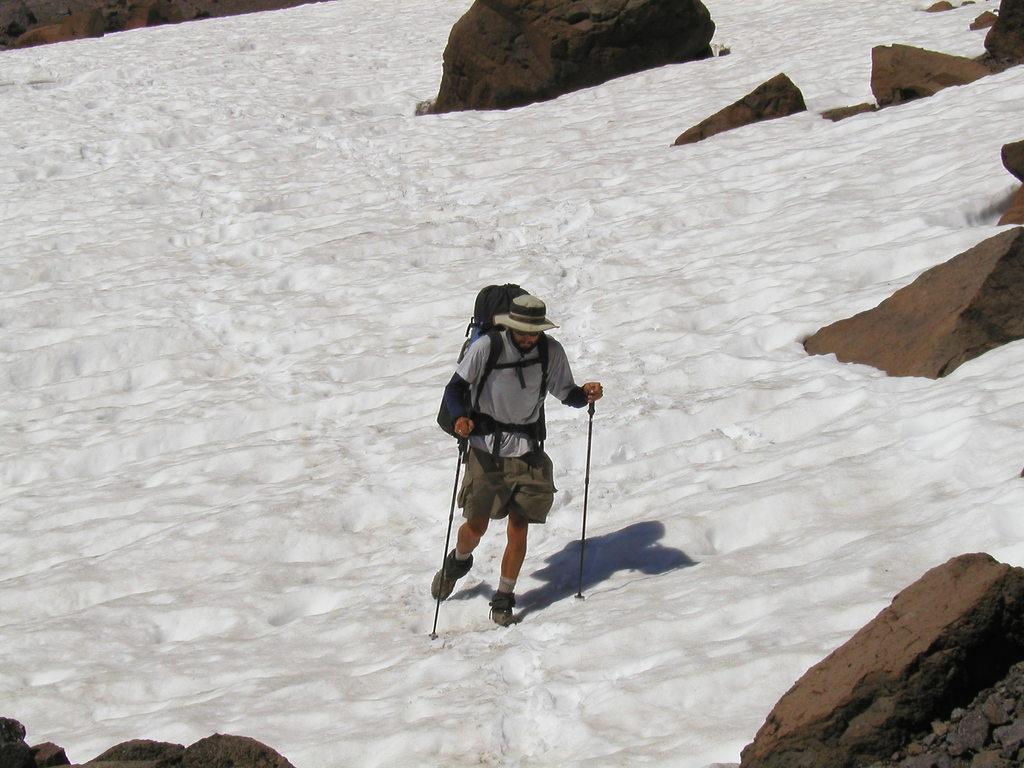In one or two sentences, can you explain what this image depicts? In this picture we can see a man wearing a backpack and hat , holding sticks in his hands and walking on the snow. These are rocks. 